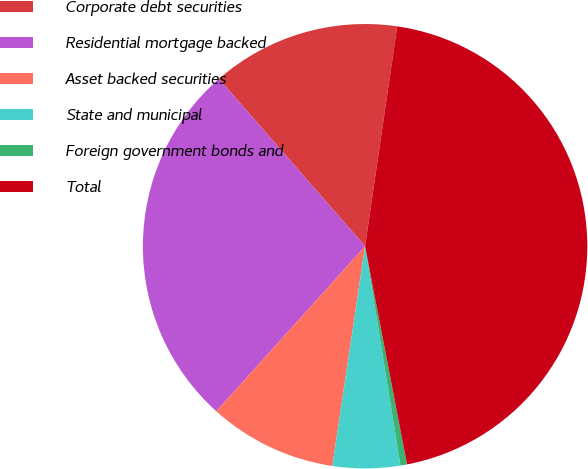Convert chart to OTSL. <chart><loc_0><loc_0><loc_500><loc_500><pie_chart><fcel>Corporate debt securities<fcel>Residential mortgage backed<fcel>Asset backed securities<fcel>State and municipal<fcel>Foreign government bonds and<fcel>Total<nl><fcel>13.74%<fcel>26.9%<fcel>9.32%<fcel>4.9%<fcel>0.48%<fcel>44.67%<nl></chart> 